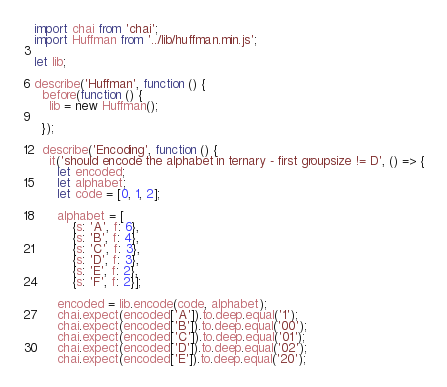Convert code to text. <code><loc_0><loc_0><loc_500><loc_500><_JavaScript_>import chai from 'chai';
import Huffman from '../lib/huffman.min.js';

let lib;

describe('Huffman', function () {
  before(function () {
    lib = new Huffman();

  });

  describe('Encoding', function () {
    it('should encode the alphabet in ternary - first groupsize != D', () => {
      let encoded;
      let alphabet;
      let code = [0, 1, 2];

      alphabet = [
          {s: 'A', f: 6},
          {s: 'B', f: 4},
          {s: 'C', f: 3},
          {s: 'D', f: 3},
          {s: 'E', f: 2},
          {s: 'F', f: 2}];

      encoded = lib.encode(code, alphabet);
      chai.expect(encoded['A']).to.deep.equal('1');
      chai.expect(encoded['B']).to.deep.equal('00');
      chai.expect(encoded['C']).to.deep.equal('01');
      chai.expect(encoded['D']).to.deep.equal('02');
      chai.expect(encoded['E']).to.deep.equal('20');</code> 